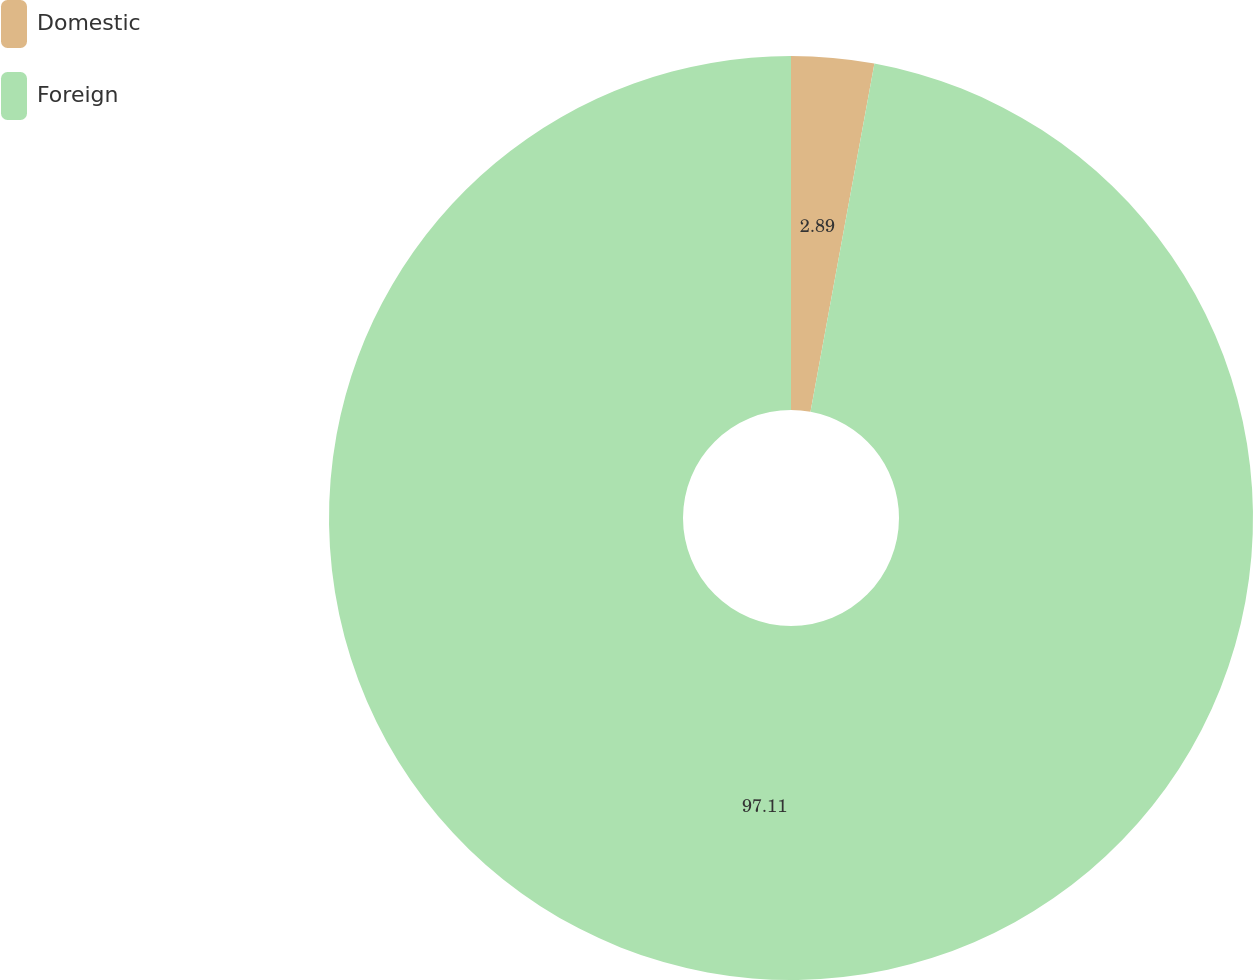Convert chart. <chart><loc_0><loc_0><loc_500><loc_500><pie_chart><fcel>Domestic<fcel>Foreign<nl><fcel>2.89%<fcel>97.11%<nl></chart> 